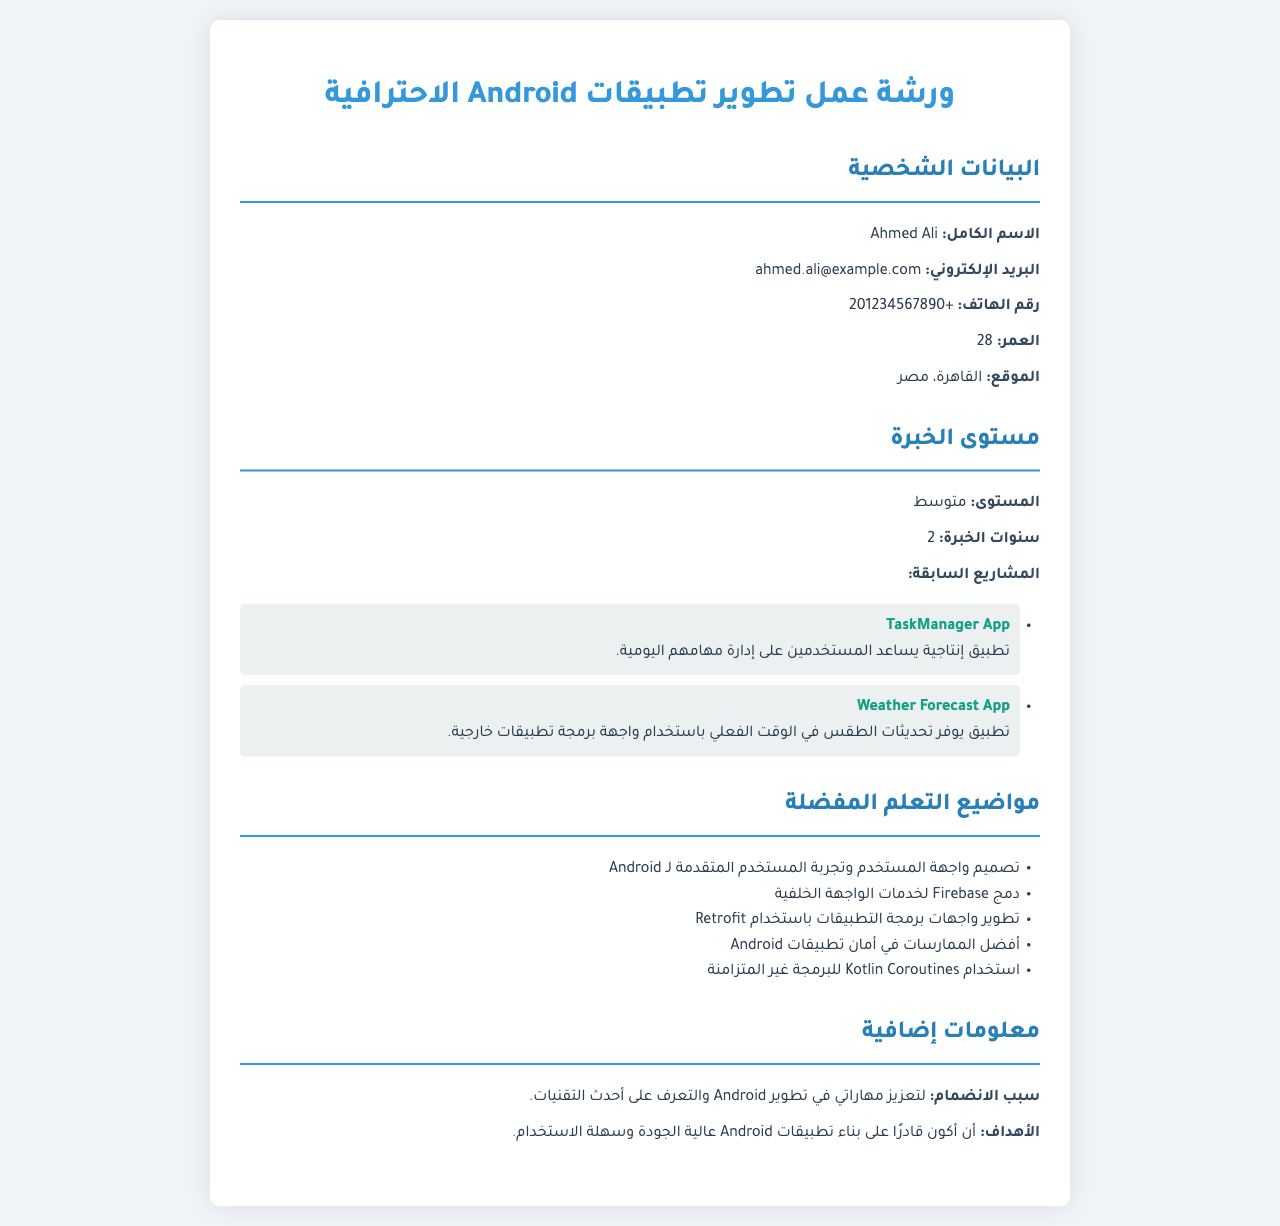ما هو الاسم الكامل؟ الاسم الكامل هو المعلومات الشخصية الأولى في الوثيقة، وهو "Ahmed Ali".
Answer: Ahmed Ali ما هو البريد الإلكتروني؟ البريد الإلكتروني هو أحد التفاصيل الشخصية المذكورة، وهو "ahmed.ali@example.com".
Answer: ahmed.ali@example.com ما هي سنوات الخبرة؟ سنوات الخبرة تذكر في قسم مستوى الخبرة، وهي "2".
Answer: 2 ما هو مستوى الخبرة؟ مستوى الخبرة موضح في الوثيقة، وهو "متوسط".
Answer: متوسط ما هو سبب الانضمام؟ سبب الانضمام موجود في قسم المعلومات الإضافية، وهو "لتعزيز مهاراتي في تطوير Android والتعرف على أحدث التقنيات".
Answer: لتعزيز مهاراتي في تطوير Android والتعرف على أحدث التقنيات ما هي مشاريع أحمد السابقة؟ يتحدث قسم مستوى الخبرة عن المشاريع السابقة مع اسميهما، وهما "TaskManager App" و "Weather Forecast App".
Answer: TaskManager App, Weather Forecast App ما هو الموضوع المفضل للتعلم الأول؟ الموضوعات المفضلة للتعلم مذكورة في قسم خاص، والموضوع الأول هو "تصميم واجهة المستخدم وتجربة المستخدم المتقدمة لـ Android".
Answer: تصميم واجهة المستخدم وتجربة المستخدم المتقدمة لـ Android ما هو الهدف من الانضمام؟ يوضح قسم المعلومات الإضافية الهدف، وهو "أن أكون قادرًا على بناء تطبيقات Android عالية الجودة وسهلة الاستخدام".
Answer: أن أكون قادرًا على بناء تطبيقات Android عالية الجودة وسهلة الاستخدام كم عدد المواضيع الثقافية المفضلة في وثيقة تسجيل؟ الوثيقة تضم خمسة مواضيع مفضلة للتعلم، وهي المذكورة في قسم المواضيع.
Answer: 5 